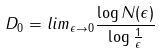<formula> <loc_0><loc_0><loc_500><loc_500>D _ { 0 } = l i m _ { \epsilon \rightarrow 0 } \frac { \log N ( \epsilon ) } { \log \frac { 1 } { \epsilon } }</formula> 